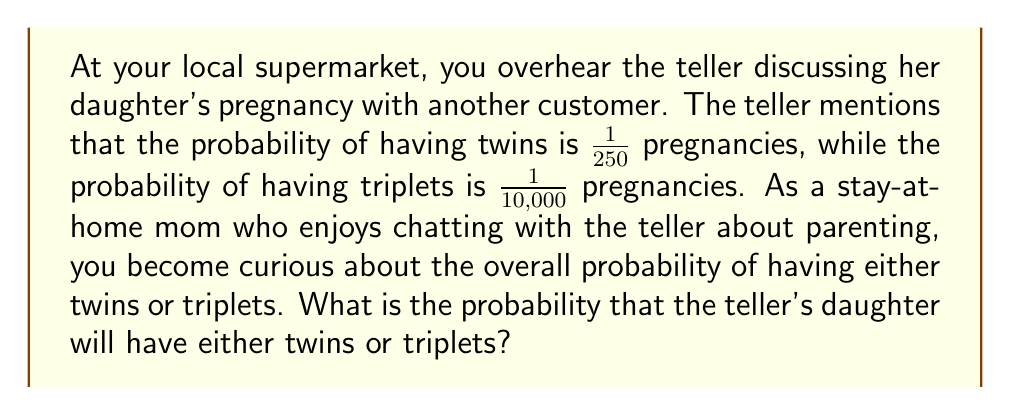Show me your answer to this math problem. Let's approach this step-by-step:

1) First, let's define our events:
   $T_2$ = having twins
   $T_3$ = having triplets

2) We're given the following probabilities:
   $P(T_2) = \frac{1}{250} = 0.004$
   $P(T_3) = \frac{1}{10000} = 0.0001$

3) We want to find $P(T_2 \text{ or } T_3)$, which is the union of these events.

4) The probability of the union of two events is given by:
   $P(A \text{ or } B) = P(A) + P(B) - P(A \text{ and } B)$

5) In this case, having twins and triplets are mutually exclusive events (they cannot occur simultaneously), so $P(T_2 \text{ and } T_3) = 0$

6) Therefore:
   $P(T_2 \text{ or } T_3) = P(T_2) + P(T_3)$

7) Substituting the values:
   $P(T_2 \text{ or } T_3) = 0.004 + 0.0001 = 0.0041$

8) To express this as a fraction:
   $\frac{41}{10000} = \frac{1}{243.9}$, which we can round to $\frac{1}{244}$
Answer: $\frac{1}{244}$ or approximately 0.0041 